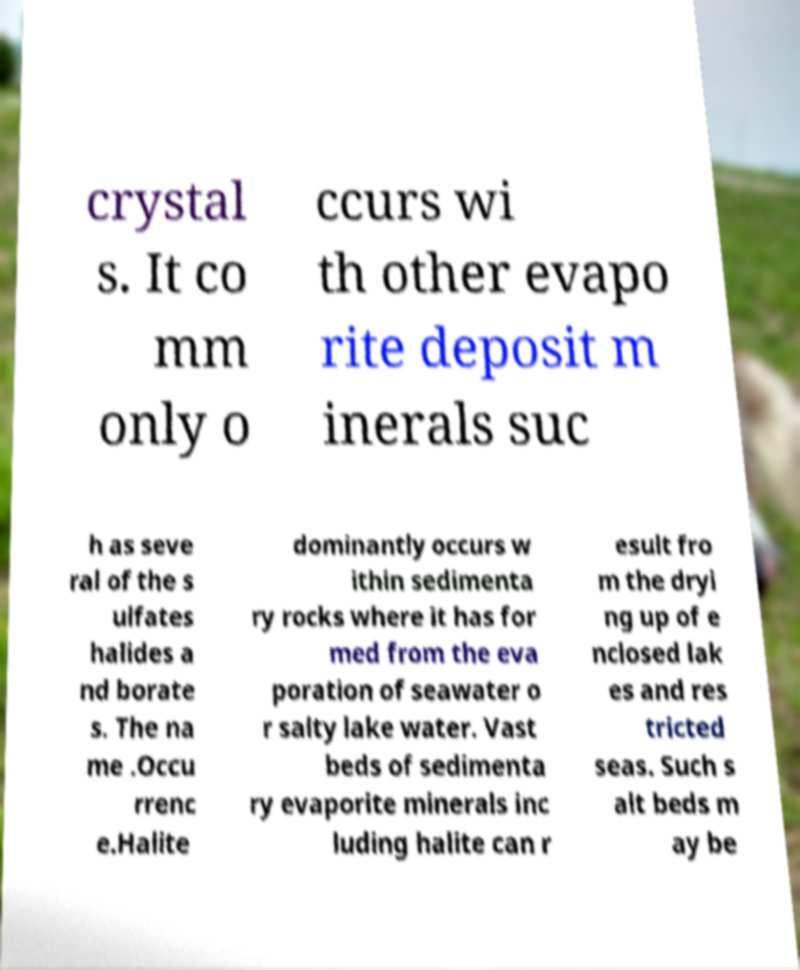Can you accurately transcribe the text from the provided image for me? crystal s. It co mm only o ccurs wi th other evapo rite deposit m inerals suc h as seve ral of the s ulfates halides a nd borate s. The na me .Occu rrenc e.Halite dominantly occurs w ithin sedimenta ry rocks where it has for med from the eva poration of seawater o r salty lake water. Vast beds of sedimenta ry evaporite minerals inc luding halite can r esult fro m the dryi ng up of e nclosed lak es and res tricted seas. Such s alt beds m ay be 